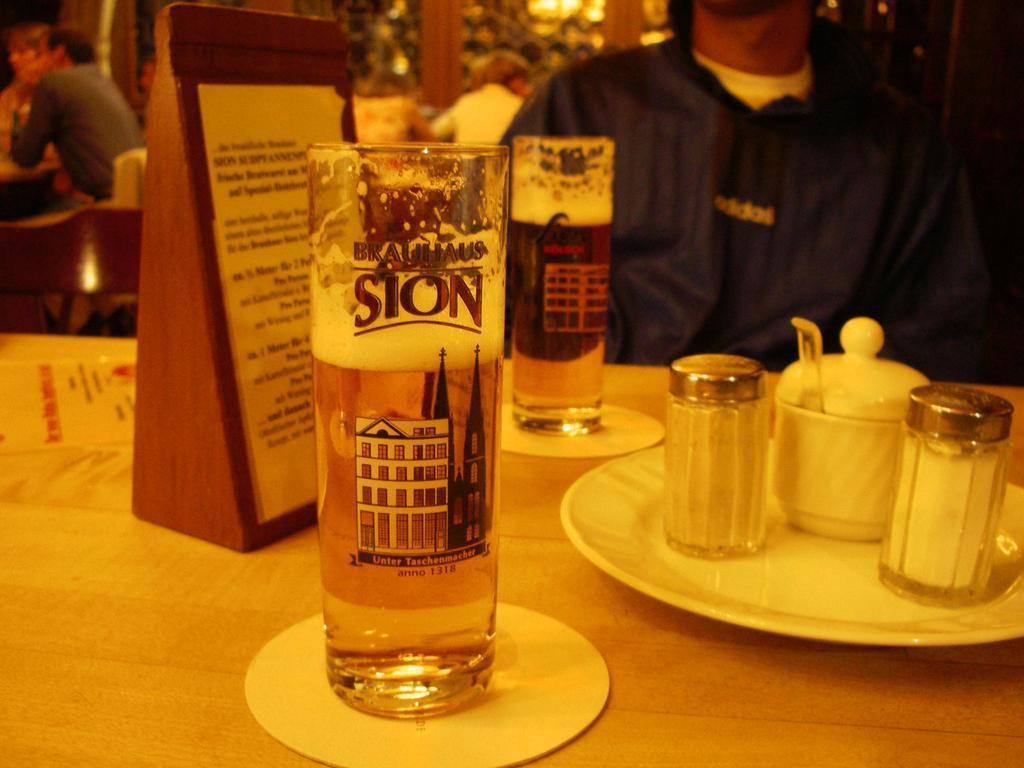<image>
Provide a brief description of the given image. A glass of beer has the word Sion on it along with a picture of a white building. 